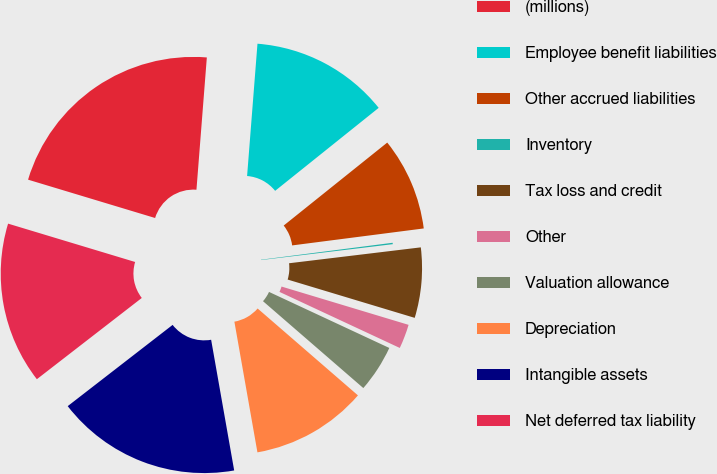Convert chart. <chart><loc_0><loc_0><loc_500><loc_500><pie_chart><fcel>(millions)<fcel>Employee benefit liabilities<fcel>Other accrued liabilities<fcel>Inventory<fcel>Tax loss and credit<fcel>Other<fcel>Valuation allowance<fcel>Depreciation<fcel>Intangible assets<fcel>Net deferred tax liability<nl><fcel>21.58%<fcel>13.0%<fcel>8.71%<fcel>0.13%<fcel>6.57%<fcel>2.28%<fcel>4.42%<fcel>10.86%<fcel>17.29%<fcel>15.15%<nl></chart> 